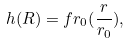Convert formula to latex. <formula><loc_0><loc_0><loc_500><loc_500>h ( R ) = f r _ { 0 } ( \frac { r } { r _ { 0 } } ) ,</formula> 